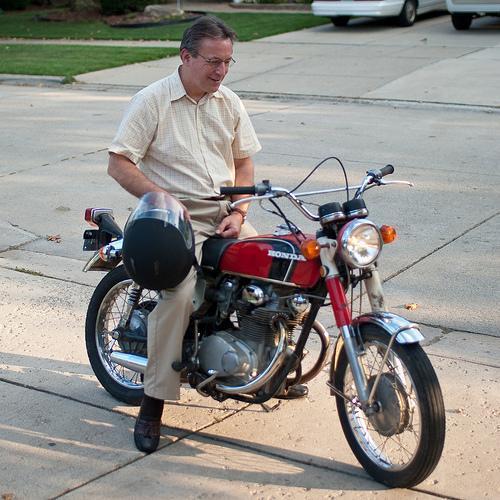How many men are wearing glasses?
Give a very brief answer. 1. How many cars are parked in the driveway across the street?
Give a very brief answer. 2. 